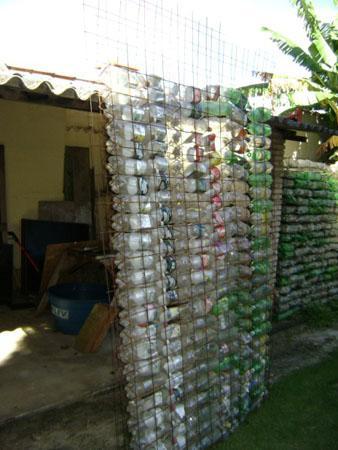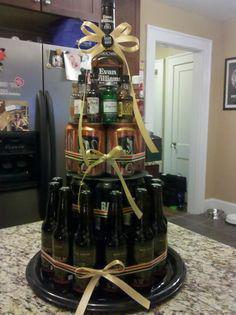The first image is the image on the left, the second image is the image on the right. Assess this claim about the two images: "The right image shows label-less glass bottles of various colors strung on rows of vertical bars, with some rightside-up and some upside-down.". Correct or not? Answer yes or no. No. The first image is the image on the left, the second image is the image on the right. Assess this claim about the two images: "Some bottles have liquor in them.". Correct or not? Answer yes or no. Yes. 